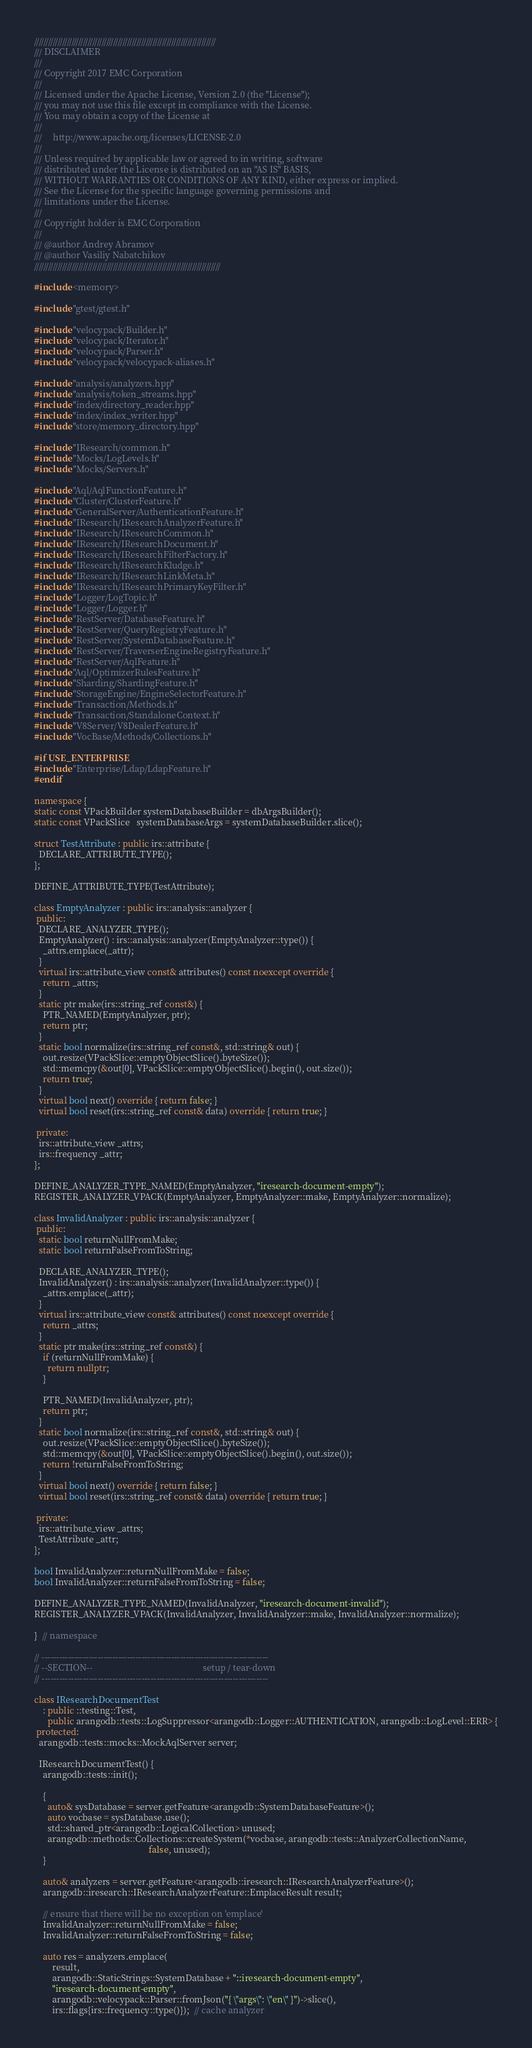<code> <loc_0><loc_0><loc_500><loc_500><_C++_>//////////////////////////////////////////////////////////////////////////////
/// DISCLAIMER
///
/// Copyright 2017 EMC Corporation
///
/// Licensed under the Apache License, Version 2.0 (the "License");
/// you may not use this file except in compliance with the License.
/// You may obtain a copy of the License at
///
///     http://www.apache.org/licenses/LICENSE-2.0
///
/// Unless required by applicable law or agreed to in writing, software
/// distributed under the License is distributed on an "AS IS" BASIS,
/// WITHOUT WARRANTIES OR CONDITIONS OF ANY KIND, either express or implied.
/// See the License for the specific language governing permissions and
/// limitations under the License.
///
/// Copyright holder is EMC Corporation
///
/// @author Andrey Abramov
/// @author Vasiliy Nabatchikov
////////////////////////////////////////////////////////////////////////////////

#include <memory>

#include "gtest/gtest.h"

#include "velocypack/Builder.h"
#include "velocypack/Iterator.h"
#include "velocypack/Parser.h"
#include "velocypack/velocypack-aliases.h"

#include "analysis/analyzers.hpp"
#include "analysis/token_streams.hpp"
#include "index/directory_reader.hpp"
#include "index/index_writer.hpp"
#include "store/memory_directory.hpp"

#include "IResearch/common.h"
#include "Mocks/LogLevels.h"
#include "Mocks/Servers.h"

#include "Aql/AqlFunctionFeature.h"
#include "Cluster/ClusterFeature.h"
#include "GeneralServer/AuthenticationFeature.h"
#include "IResearch/IResearchAnalyzerFeature.h"
#include "IResearch/IResearchCommon.h"
#include "IResearch/IResearchDocument.h"
#include "IResearch/IResearchFilterFactory.h"
#include "IResearch/IResearchKludge.h"
#include "IResearch/IResearchLinkMeta.h"
#include "IResearch/IResearchPrimaryKeyFilter.h"
#include "Logger/LogTopic.h"
#include "Logger/Logger.h"
#include "RestServer/DatabaseFeature.h"
#include "RestServer/QueryRegistryFeature.h"
#include "RestServer/SystemDatabaseFeature.h"
#include "RestServer/TraverserEngineRegistryFeature.h"
#include "RestServer/AqlFeature.h"
#include "Aql/OptimizerRulesFeature.h"
#include "Sharding/ShardingFeature.h"
#include "StorageEngine/EngineSelectorFeature.h"
#include "Transaction/Methods.h"
#include "Transaction/StandaloneContext.h"
#include "V8Server/V8DealerFeature.h"
#include "VocBase/Methods/Collections.h"

#if USE_ENTERPRISE
#include "Enterprise/Ldap/LdapFeature.h"
#endif

namespace {
static const VPackBuilder systemDatabaseBuilder = dbArgsBuilder();
static const VPackSlice   systemDatabaseArgs = systemDatabaseBuilder.slice();

struct TestAttribute : public irs::attribute {
  DECLARE_ATTRIBUTE_TYPE();
};

DEFINE_ATTRIBUTE_TYPE(TestAttribute);

class EmptyAnalyzer : public irs::analysis::analyzer {
 public:
  DECLARE_ANALYZER_TYPE();
  EmptyAnalyzer() : irs::analysis::analyzer(EmptyAnalyzer::type()) {
    _attrs.emplace(_attr);
  }
  virtual irs::attribute_view const& attributes() const noexcept override {
    return _attrs;
  }
  static ptr make(irs::string_ref const&) {
    PTR_NAMED(EmptyAnalyzer, ptr);
    return ptr;
  }
  static bool normalize(irs::string_ref const&, std::string& out) {
    out.resize(VPackSlice::emptyObjectSlice().byteSize());
    std::memcpy(&out[0], VPackSlice::emptyObjectSlice().begin(), out.size());
    return true;
  }
  virtual bool next() override { return false; }
  virtual bool reset(irs::string_ref const& data) override { return true; }

 private:
  irs::attribute_view _attrs;
  irs::frequency _attr;
};

DEFINE_ANALYZER_TYPE_NAMED(EmptyAnalyzer, "iresearch-document-empty");
REGISTER_ANALYZER_VPACK(EmptyAnalyzer, EmptyAnalyzer::make, EmptyAnalyzer::normalize);

class InvalidAnalyzer : public irs::analysis::analyzer {
 public:
  static bool returnNullFromMake;
  static bool returnFalseFromToString;

  DECLARE_ANALYZER_TYPE();
  InvalidAnalyzer() : irs::analysis::analyzer(InvalidAnalyzer::type()) {
    _attrs.emplace(_attr);
  }
  virtual irs::attribute_view const& attributes() const noexcept override {
    return _attrs;
  }
  static ptr make(irs::string_ref const&) {
    if (returnNullFromMake) {
      return nullptr;
    }

    PTR_NAMED(InvalidAnalyzer, ptr);
    return ptr;
  }
  static bool normalize(irs::string_ref const&, std::string& out) {
    out.resize(VPackSlice::emptyObjectSlice().byteSize());
    std::memcpy(&out[0], VPackSlice::emptyObjectSlice().begin(), out.size());
    return !returnFalseFromToString;
  }
  virtual bool next() override { return false; }
  virtual bool reset(irs::string_ref const& data) override { return true; }

 private:
  irs::attribute_view _attrs;
  TestAttribute _attr;
};

bool InvalidAnalyzer::returnNullFromMake = false;
bool InvalidAnalyzer::returnFalseFromToString = false;

DEFINE_ANALYZER_TYPE_NAMED(InvalidAnalyzer, "iresearch-document-invalid");
REGISTER_ANALYZER_VPACK(InvalidAnalyzer, InvalidAnalyzer::make, InvalidAnalyzer::normalize);

}  // namespace

// -----------------------------------------------------------------------------
// --SECTION--                                                 setup / tear-down
// -----------------------------------------------------------------------------

class IResearchDocumentTest
    : public ::testing::Test,
      public arangodb::tests::LogSuppressor<arangodb::Logger::AUTHENTICATION, arangodb::LogLevel::ERR> {
 protected:
  arangodb::tests::mocks::MockAqlServer server;

  IResearchDocumentTest() {
    arangodb::tests::init();

    {
      auto& sysDatabase = server.getFeature<arangodb::SystemDatabaseFeature>();
      auto vocbase = sysDatabase.use();
      std::shared_ptr<arangodb::LogicalCollection> unused;
      arangodb::methods::Collections::createSystem(*vocbase, arangodb::tests::AnalyzerCollectionName,
                                                   false, unused);
    }

    auto& analyzers = server.getFeature<arangodb::iresearch::IResearchAnalyzerFeature>();
    arangodb::iresearch::IResearchAnalyzerFeature::EmplaceResult result;

    // ensure that there will be no exception on 'emplace'
    InvalidAnalyzer::returnNullFromMake = false;
    InvalidAnalyzer::returnFalseFromToString = false;

    auto res = analyzers.emplace(
        result,
        arangodb::StaticStrings::SystemDatabase + "::iresearch-document-empty",
        "iresearch-document-empty",
        arangodb::velocypack::Parser::fromJson("{ \"args\": \"en\" }")->slice(),
        irs::flags{irs::frequency::type()});  // cache analyzer</code> 